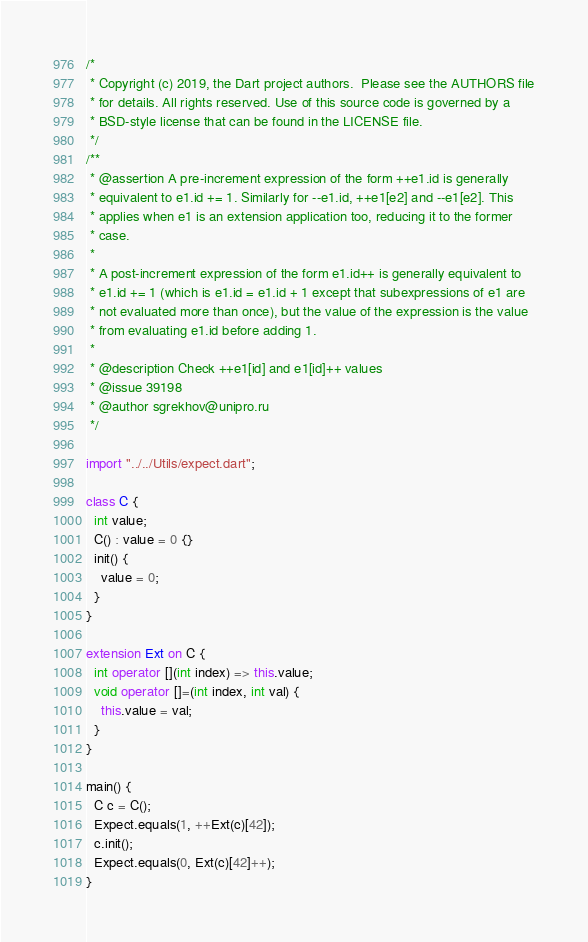Convert code to text. <code><loc_0><loc_0><loc_500><loc_500><_Dart_>/*
 * Copyright (c) 2019, the Dart project authors.  Please see the AUTHORS file
 * for details. All rights reserved. Use of this source code is governed by a
 * BSD-style license that can be found in the LICENSE file.
 */
/**
 * @assertion A pre-increment expression of the form ++e1.id is generally
 * equivalent to e1.id += 1. Similarly for --e1.id, ++e1[e2] and --e1[e2]. This
 * applies when e1 is an extension application too, reducing it to the former
 * case.
 *
 * A post-increment expression of the form e1.id++ is generally equivalent to
 * e1.id += 1 (which is e1.id = e1.id + 1 except that subexpressions of e1 are
 * not evaluated more than once), but the value of the expression is the value
 * from evaluating e1.id before adding 1.
 *
 * @description Check ++e1[id] and e1[id]++ values
 * @issue 39198
 * @author sgrekhov@unipro.ru
 */

import "../../Utils/expect.dart";

class C {
  int value;
  C() : value = 0 {}
  init() {
    value = 0;
  }
}

extension Ext on C {
  int operator [](int index) => this.value;
  void operator []=(int index, int val) {
    this.value = val;
  }
}

main() {
  C c = C();
  Expect.equals(1, ++Ext(c)[42]);
  c.init();
  Expect.equals(0, Ext(c)[42]++);
}
</code> 